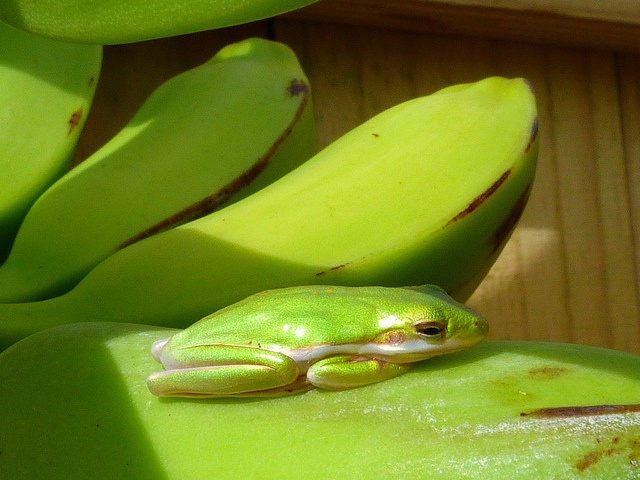Describe the objects in this image and their specific colors. I can see a banana in darkgreen, khaki, and olive tones in this image. 